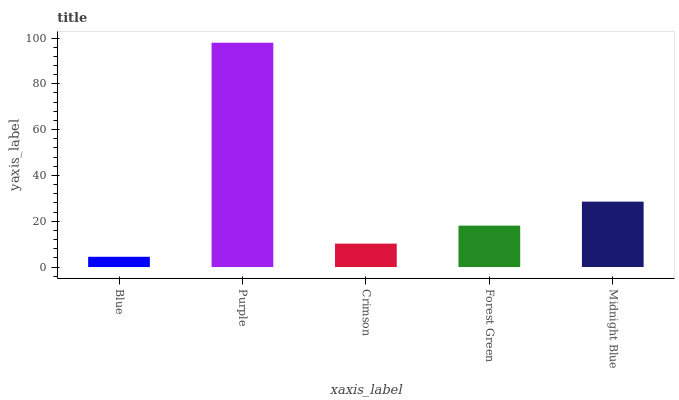Is Blue the minimum?
Answer yes or no. Yes. Is Purple the maximum?
Answer yes or no. Yes. Is Crimson the minimum?
Answer yes or no. No. Is Crimson the maximum?
Answer yes or no. No. Is Purple greater than Crimson?
Answer yes or no. Yes. Is Crimson less than Purple?
Answer yes or no. Yes. Is Crimson greater than Purple?
Answer yes or no. No. Is Purple less than Crimson?
Answer yes or no. No. Is Forest Green the high median?
Answer yes or no. Yes. Is Forest Green the low median?
Answer yes or no. Yes. Is Crimson the high median?
Answer yes or no. No. Is Crimson the low median?
Answer yes or no. No. 